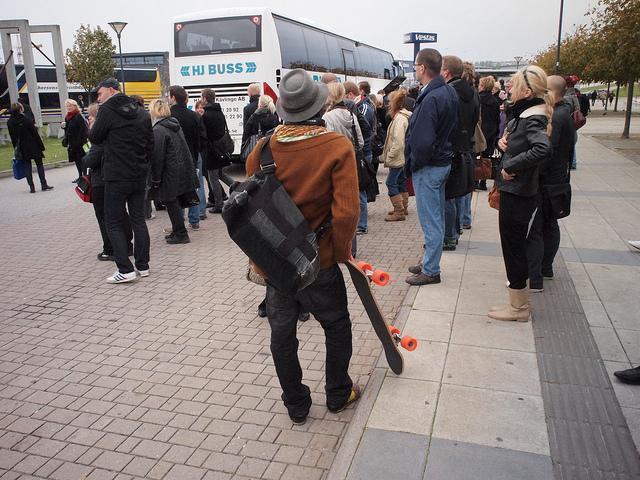What kind of bus is the white vehicle?
Make your selection from the four choices given to correctly answer the question.
Options: Tourist bus, school bus, double decker, public bus. Tourist bus. 